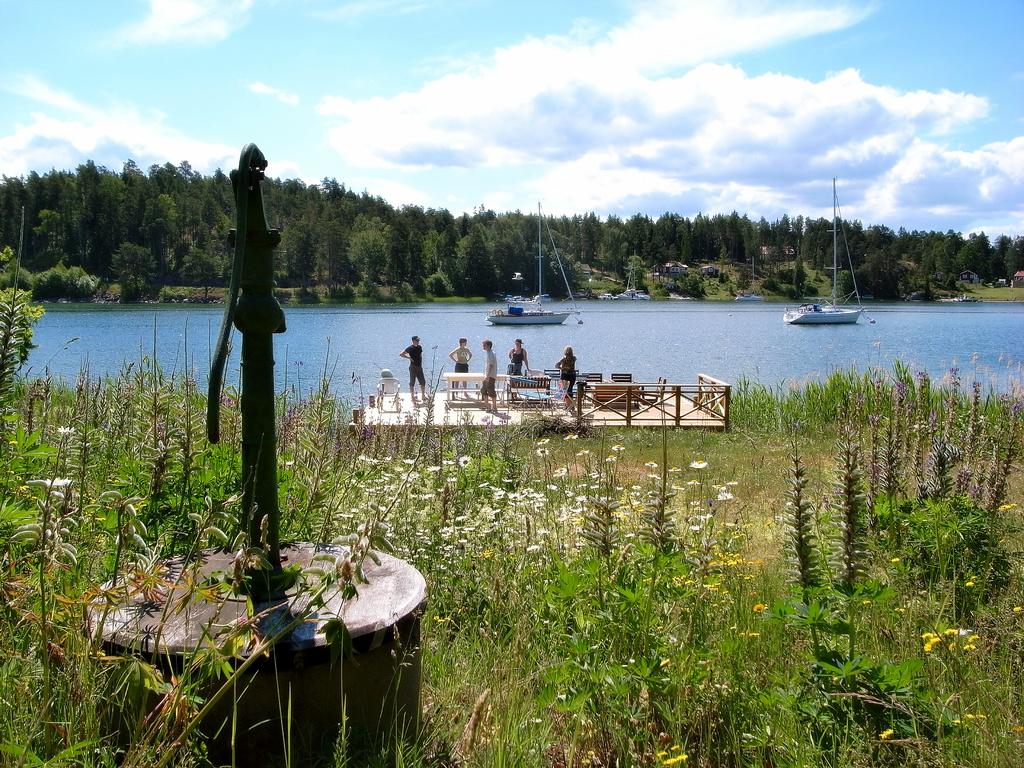How many persons are in the image? There are persons in the image, but the exact number is not specified. What structure is present in the image? There is a water pump in the image. What type of vegetation is visible in the image? There are plants and trees visible in the image. What is the primary source of water in the image? There is water visible in the image, and it is likely being drawn from the water pump. What type of transportation is present in the image? There are boats in the image. What type of buildings are present in the image? There are houses in the image. What is visible in the sky in the image? The sky is visible in the image, and there are clouds visible. Can you tell me how many parents are visible in the image? There is no mention of parents in the image, so it is not possible to determine their presence or number. What type of chair is visible in the image? There is no chair present in the image. What type of conversation is taking place between the persons in the image? There is no indication of any conversation taking place between the persons in the image. 